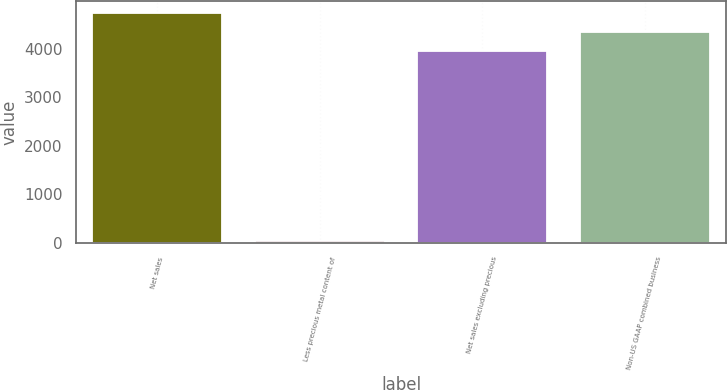Convert chart to OTSL. <chart><loc_0><loc_0><loc_500><loc_500><bar_chart><fcel>Net sales<fcel>Less precious metal content of<fcel>Net sales excluding precious<fcel>Non-US GAAP combined business<nl><fcel>4743.48<fcel>40.5<fcel>3952.9<fcel>4348.19<nl></chart> 